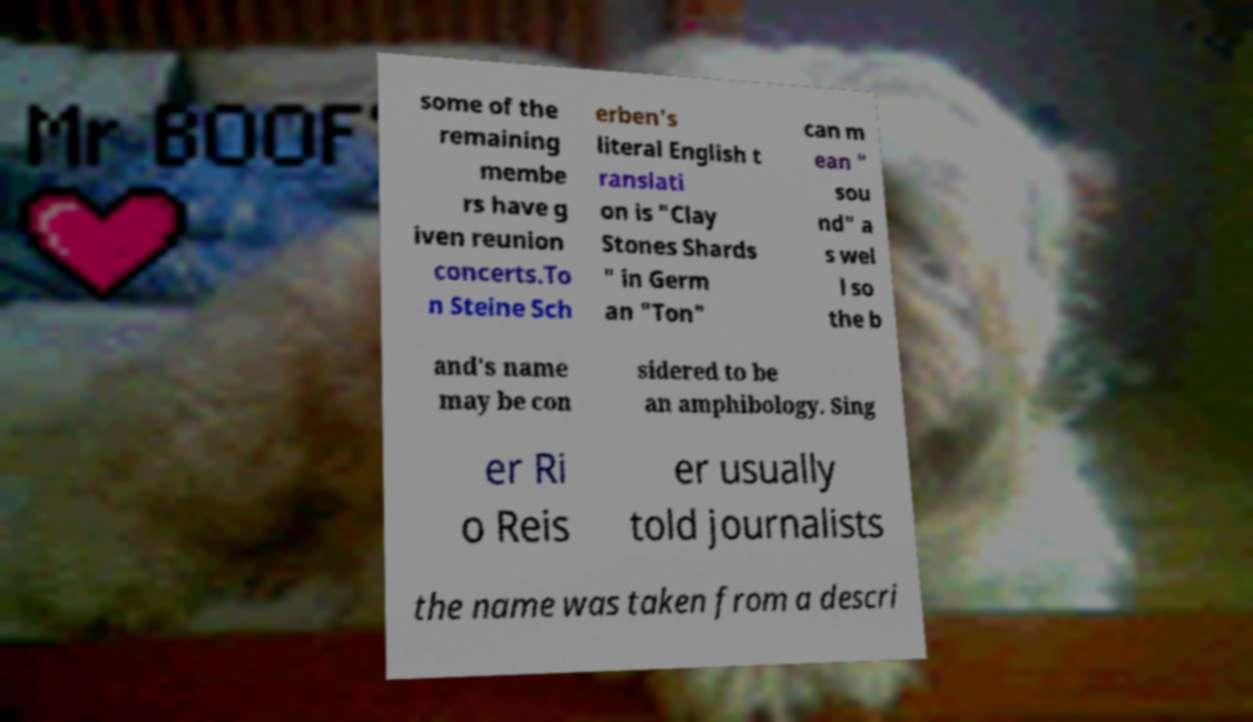What messages or text are displayed in this image? I need them in a readable, typed format. some of the remaining membe rs have g iven reunion concerts.To n Steine Sch erben's literal English t ranslati on is "Clay Stones Shards " in Germ an "Ton" can m ean " sou nd" a s wel l so the b and's name may be con sidered to be an amphibology. Sing er Ri o Reis er usually told journalists the name was taken from a descri 